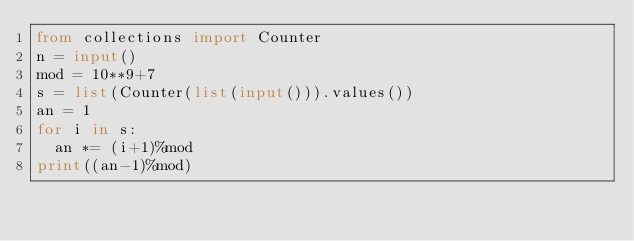Convert code to text. <code><loc_0><loc_0><loc_500><loc_500><_Python_>from collections import Counter
n = input()
mod = 10**9+7
s = list(Counter(list(input())).values())
an = 1
for i in s:
  an *= (i+1)%mod
print((an-1)%mod)</code> 